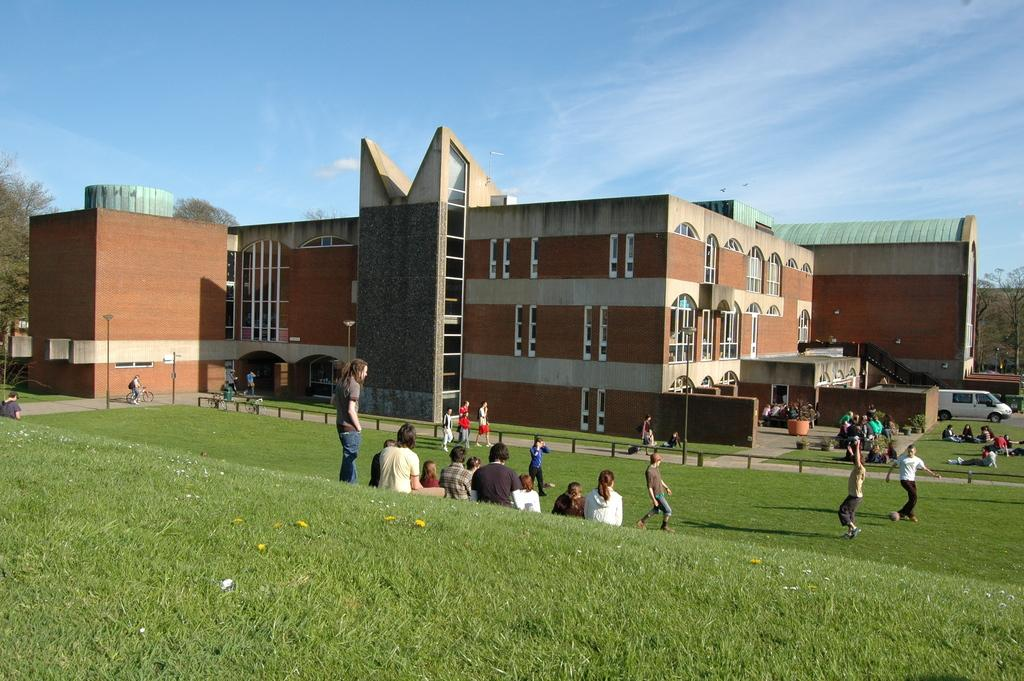What type of structures can be seen in the image? There are buildings in the image. What natural elements are present in the image? There are trees in the image. What man-made objects can be seen in the image? There are poles in the image. What type of ground cover is at the bottom of the image? There is grass at the bottom of the image. Who or what else is present in the image? There are people and a car in the image. What can be seen in the background of the image? The sky is visible in the background of the image. Can you tell me how many sisters are in the image? There is no mention of a sister in the image, so it is not possible to answer that question. What type of ocean can be seen in the image? There is no ocean present in the image; it features buildings, trees, poles, grass, people, a car, and the sky. 